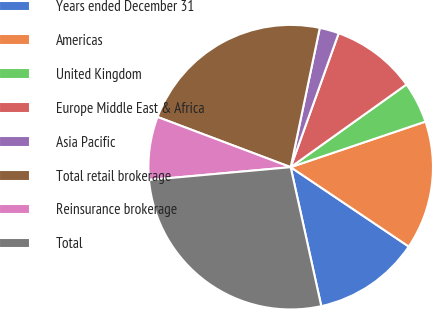Convert chart to OTSL. <chart><loc_0><loc_0><loc_500><loc_500><pie_chart><fcel>Years ended December 31<fcel>Americas<fcel>United Kingdom<fcel>Europe Middle East & Africa<fcel>Asia Pacific<fcel>Total retail brokerage<fcel>Reinsurance brokerage<fcel>Total<nl><fcel>12.13%<fcel>14.61%<fcel>4.68%<fcel>9.65%<fcel>2.2%<fcel>22.54%<fcel>7.17%<fcel>27.02%<nl></chart> 